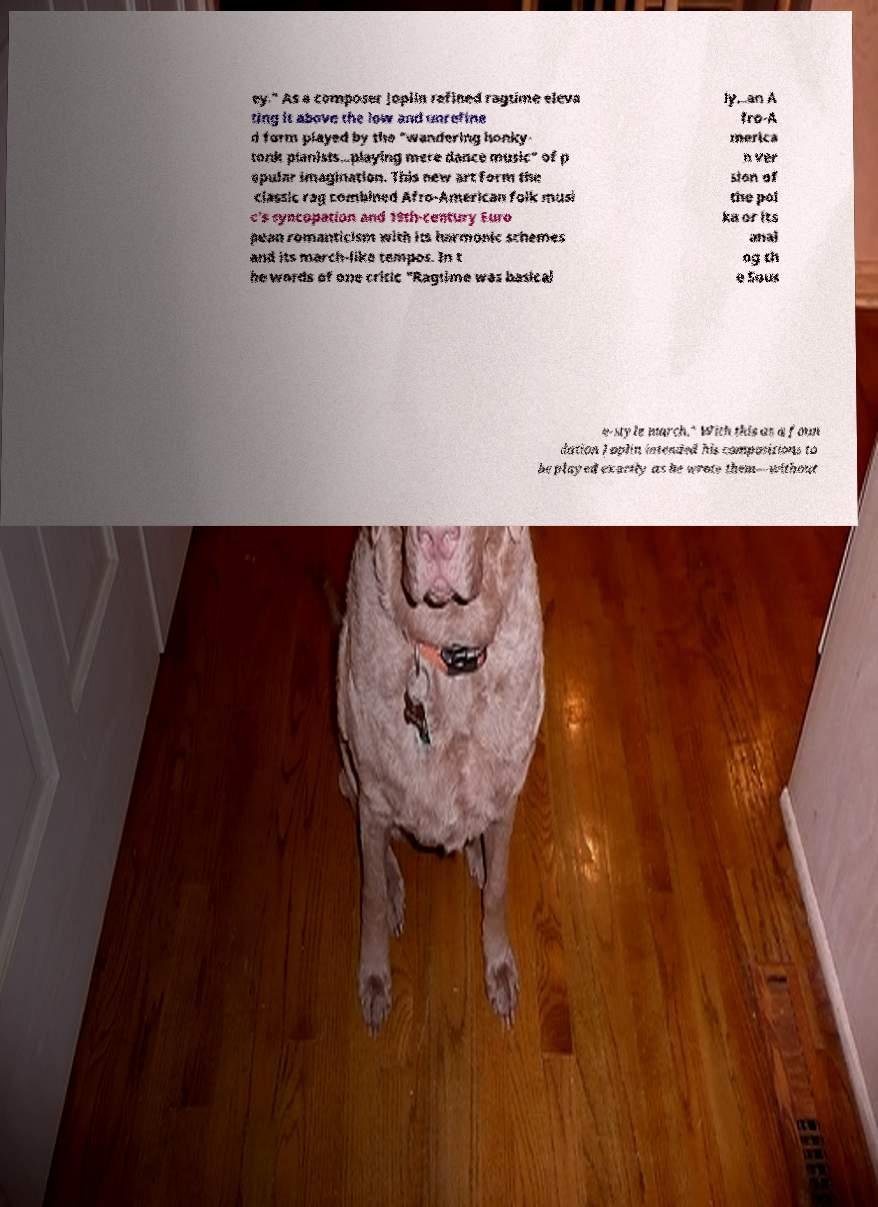Can you read and provide the text displayed in the image?This photo seems to have some interesting text. Can you extract and type it out for me? ey." As a composer Joplin refined ragtime eleva ting it above the low and unrefine d form played by the "wandering honky- tonk pianists...playing mere dance music" of p opular imagination. This new art form the classic rag combined Afro-American folk musi c's syncopation and 19th-century Euro pean romanticism with its harmonic schemes and its march-like tempos. In t he words of one critic "Ragtime was basical ly...an A fro-A merica n ver sion of the pol ka or its anal og th e Sous a-style march." With this as a foun dation Joplin intended his compositions to be played exactly as he wrote them—without 